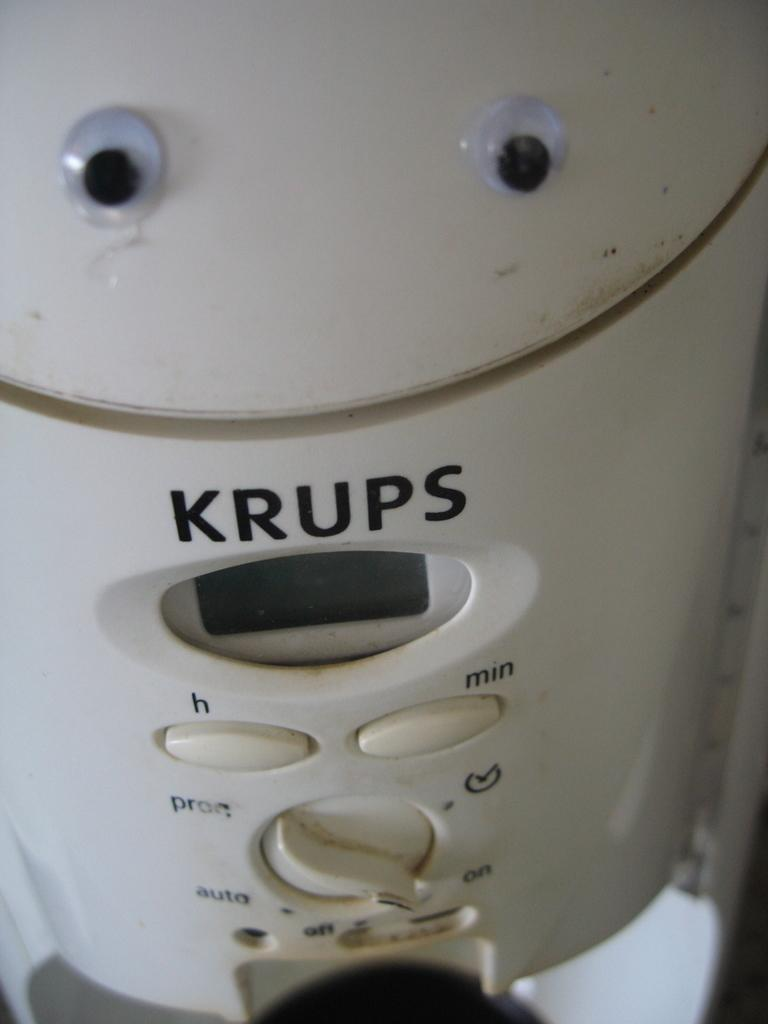<image>
Offer a succinct explanation of the picture presented. A white kitchen appliance by Krups that has a pair of googly eyes on the top. 